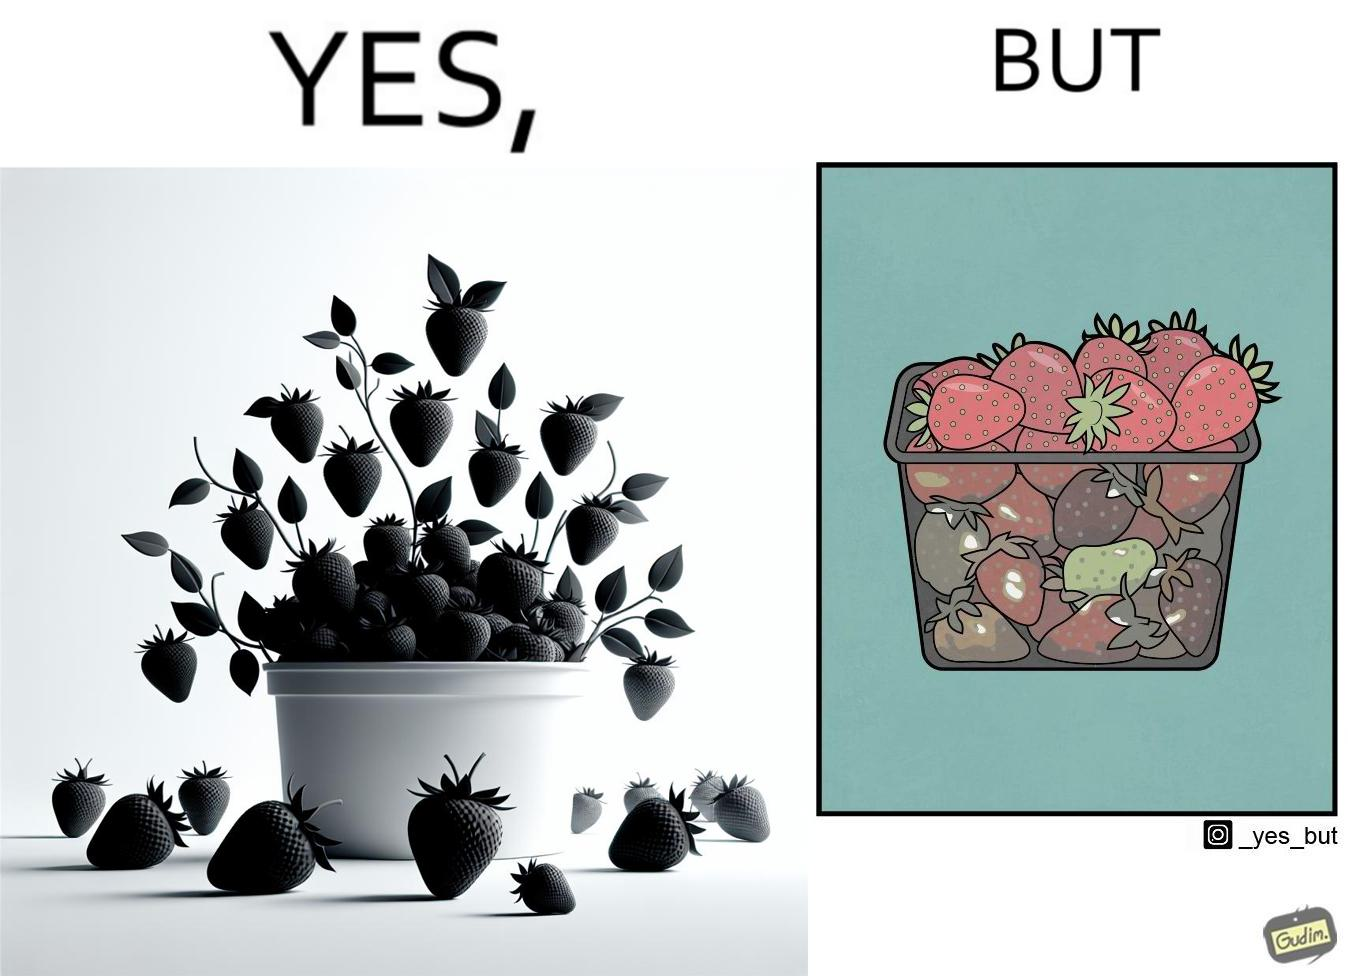What is shown in this image? the image is funny, as the strawberries in a container generally bought in retail appear fresh from the top, but the ones below them (which are generally not visible directly while buying the container of strawberries) are low quality/spoilt, revealing the tactics that retail uses to pass on low-quality products to innocent consumers. 